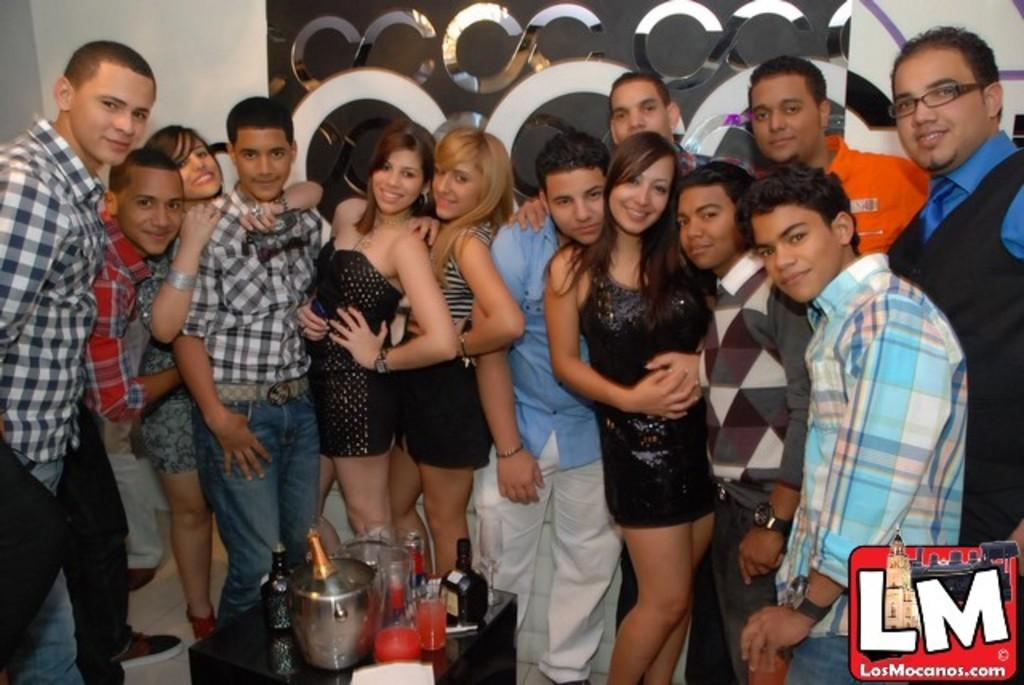How many people are in the image? There is a group of people in the image. What are the people in the image doing? The people are posing for a photo. What can be seen in the foreground of the image? There are bottles, glasses, and other items in the foreground of the image. How many beds are visible in the image? There are no beds visible in the image. What type of bag can be seen in the middle of the image? There is no bag present in the image. 